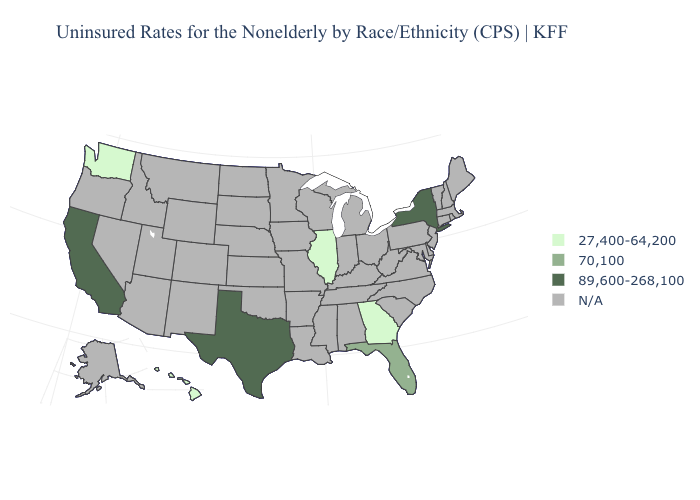What is the value of Delaware?
Keep it brief. N/A. What is the value of Tennessee?
Quick response, please. N/A. What is the value of Wisconsin?
Quick response, please. N/A. What is the highest value in the West ?
Concise answer only. 89,600-268,100. Name the states that have a value in the range 89,600-268,100?
Quick response, please. California, New York, Texas. Name the states that have a value in the range 89,600-268,100?
Be succinct. California, New York, Texas. Is the legend a continuous bar?
Be succinct. No. Does Washington have the highest value in the West?
Give a very brief answer. No. What is the value of South Dakota?
Quick response, please. N/A. Is the legend a continuous bar?
Be succinct. No. Does the map have missing data?
Give a very brief answer. Yes. What is the value of Vermont?
Short answer required. N/A. What is the value of New York?
Give a very brief answer. 89,600-268,100. 